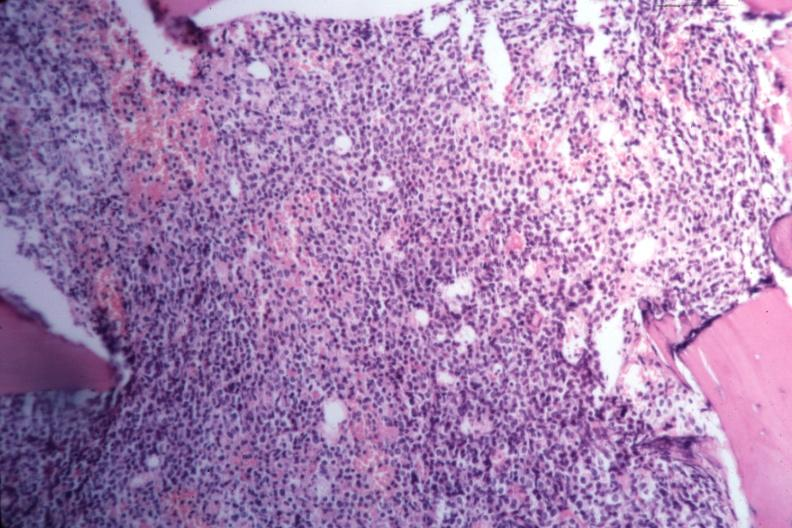s blood present?
Answer the question using a single word or phrase. No 